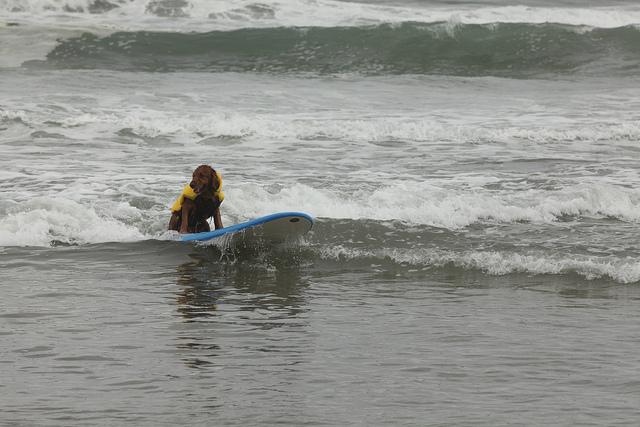Are the waves in this body of water choppy?
Be succinct. Yes. What is the purpose of the yellow vest?
Quick response, please. Safety. Is the dog riding a surfboard?
Quick response, please. Yes. What is the dog wearing?
Short answer required. Life jacket. 